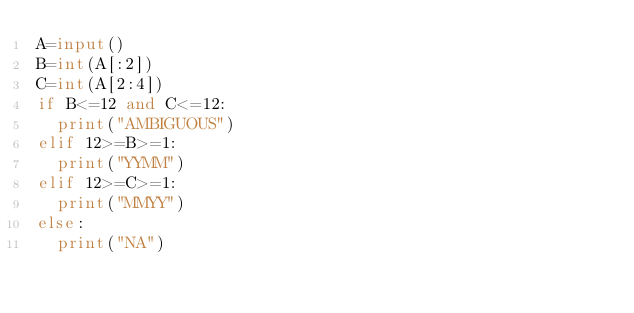Convert code to text. <code><loc_0><loc_0><loc_500><loc_500><_Python_>A=input()
B=int(A[:2])
C=int(A[2:4])
if B<=12 and C<=12:
  print("AMBIGUOUS")
elif 12>=B>=1:
  print("YYMM")
elif 12>=C>=1:
  print("MMYY")
else:
  print("NA")</code> 